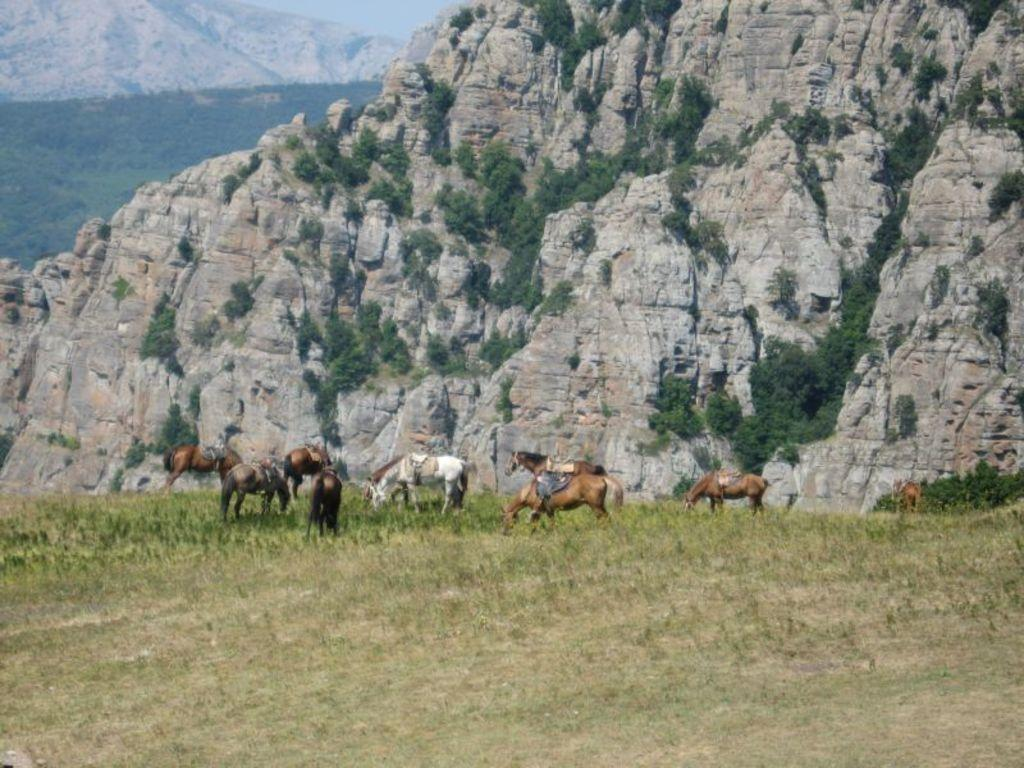What type of vegetation can be seen at the bottom of the image? There is grass at the bottom of the image. What can be seen in the background of the image? There are hills and the sky visible in the background of the image. What type of curtain can be seen hanging from the trees in the image? There is no curtain present in the image; it features animals, grass, hills, and the sky. How do the animals maintain their balance while walking on the hills in the image? The image does not show the animals walking on the hills, so it is not possible to determine how they maintain their balance. 